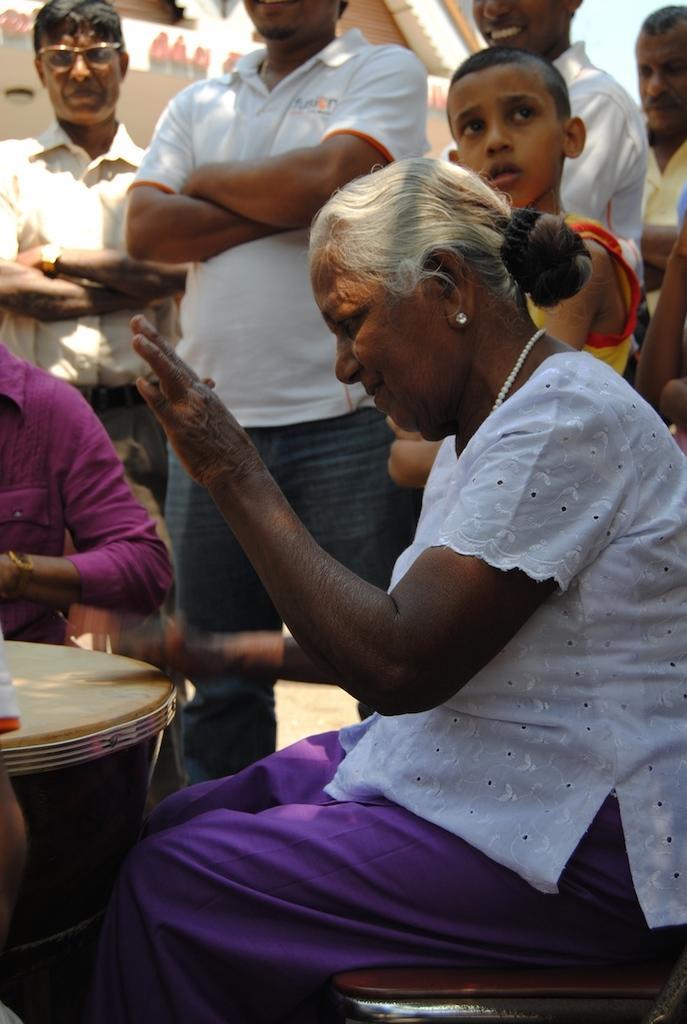How would you summarize this image in a sentence or two? In this image i can see a woman sitting in on a chair and the other person sitting in front of a woman there is a table, at the back ground i can see few persons standing , a building and a sky. 